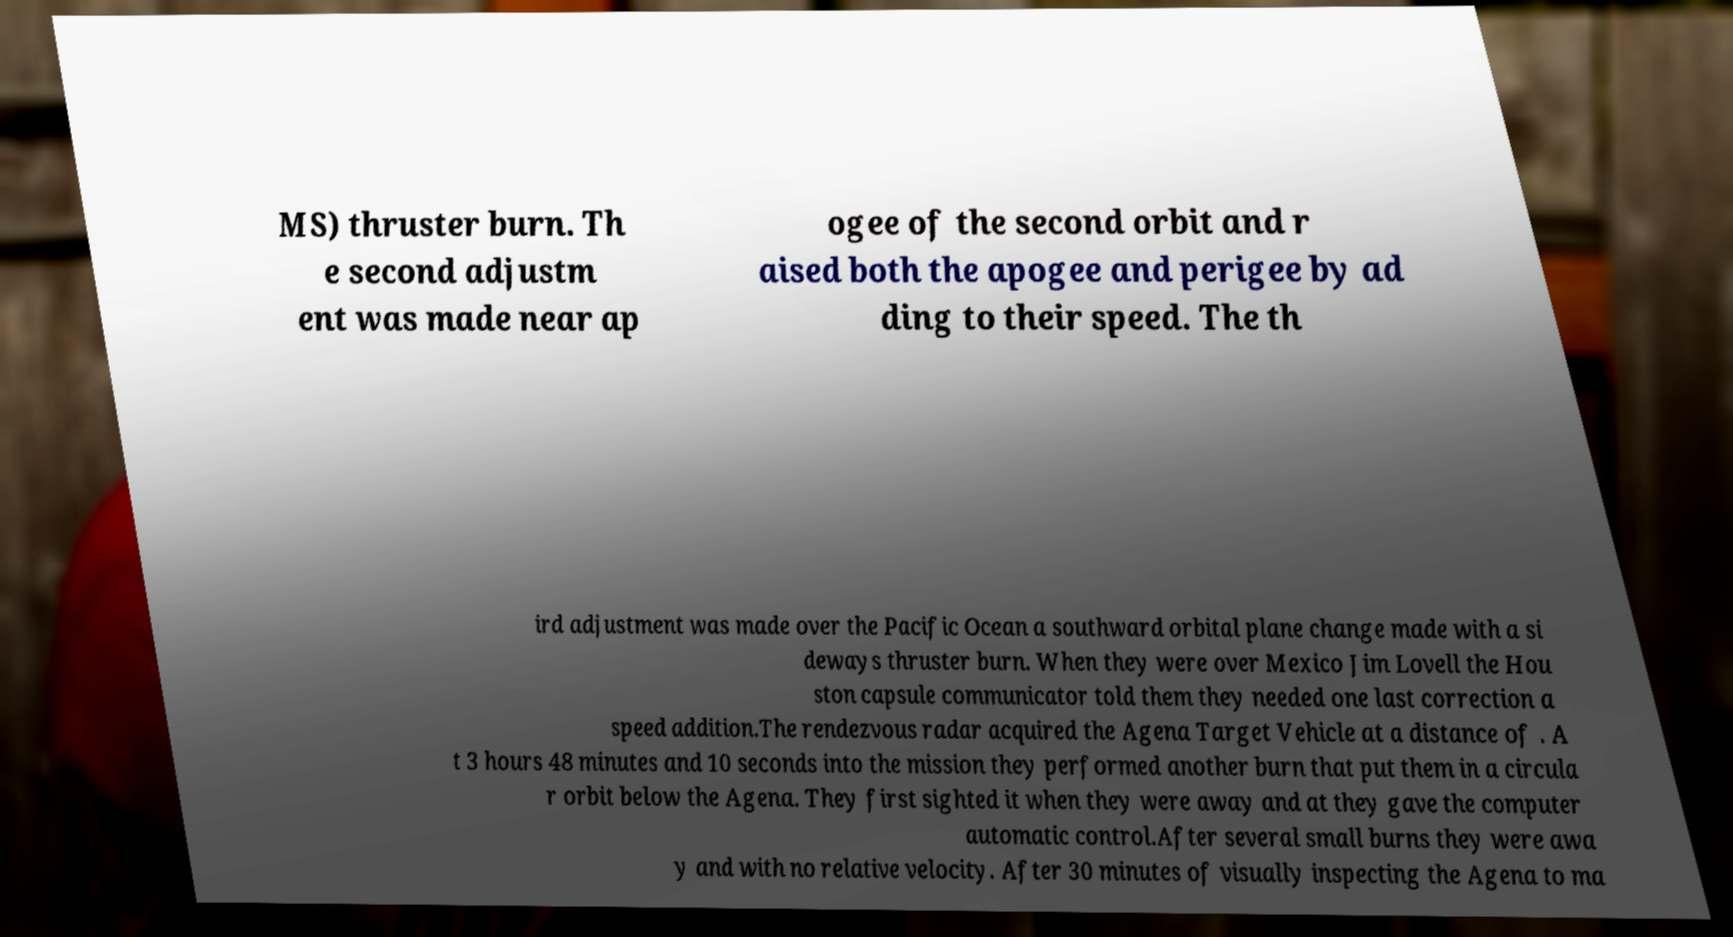Can you read and provide the text displayed in the image?This photo seems to have some interesting text. Can you extract and type it out for me? MS) thruster burn. Th e second adjustm ent was made near ap ogee of the second orbit and r aised both the apogee and perigee by ad ding to their speed. The th ird adjustment was made over the Pacific Ocean a southward orbital plane change made with a si deways thruster burn. When they were over Mexico Jim Lovell the Hou ston capsule communicator told them they needed one last correction a speed addition.The rendezvous radar acquired the Agena Target Vehicle at a distance of . A t 3 hours 48 minutes and 10 seconds into the mission they performed another burn that put them in a circula r orbit below the Agena. They first sighted it when they were away and at they gave the computer automatic control.After several small burns they were awa y and with no relative velocity. After 30 minutes of visually inspecting the Agena to ma 